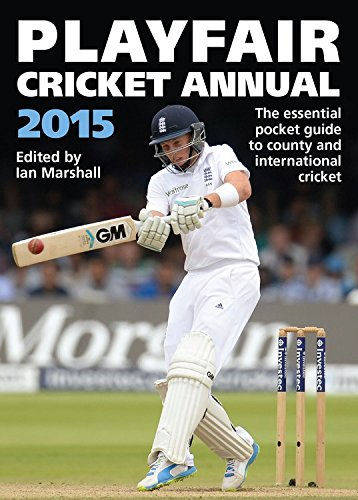Can you describe the image on the cover of this book? The cover features a scene from a cricket match with a batsman in the midst of a shot, wearing traditional cricket attire. This emphasizes the book's focus on professional cricket. 